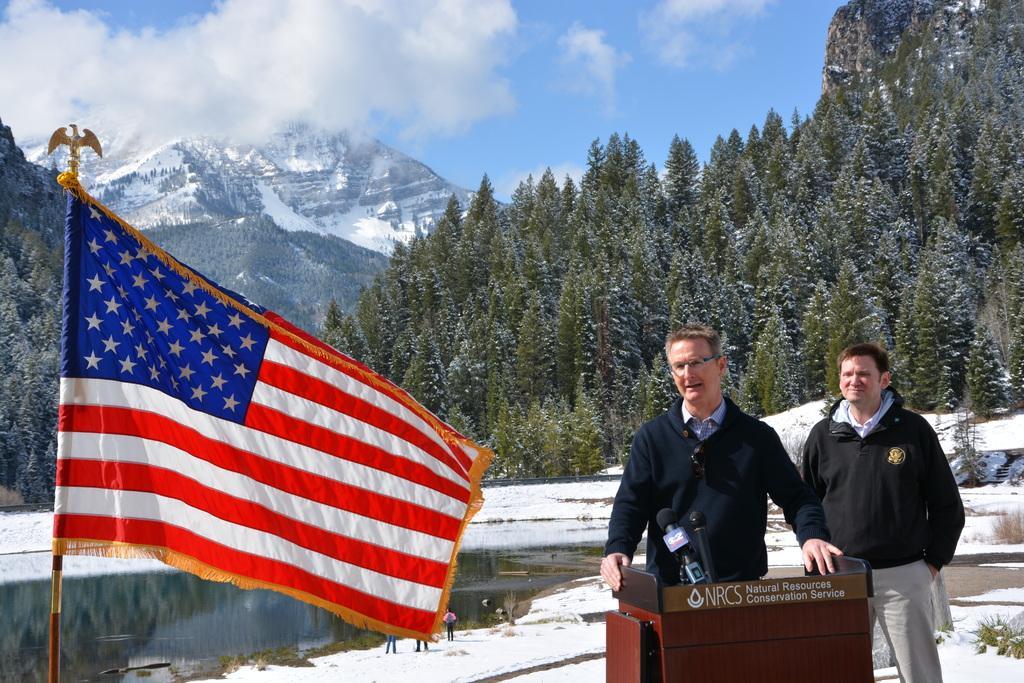In one or two sentences, can you explain what this image depicts? In this image we can see some persons standing, among them one person is standing in front of the podium, on the podium, we can see some text and mice, there are some trees, mountains and water, in the background we can see the sky with clouds. 